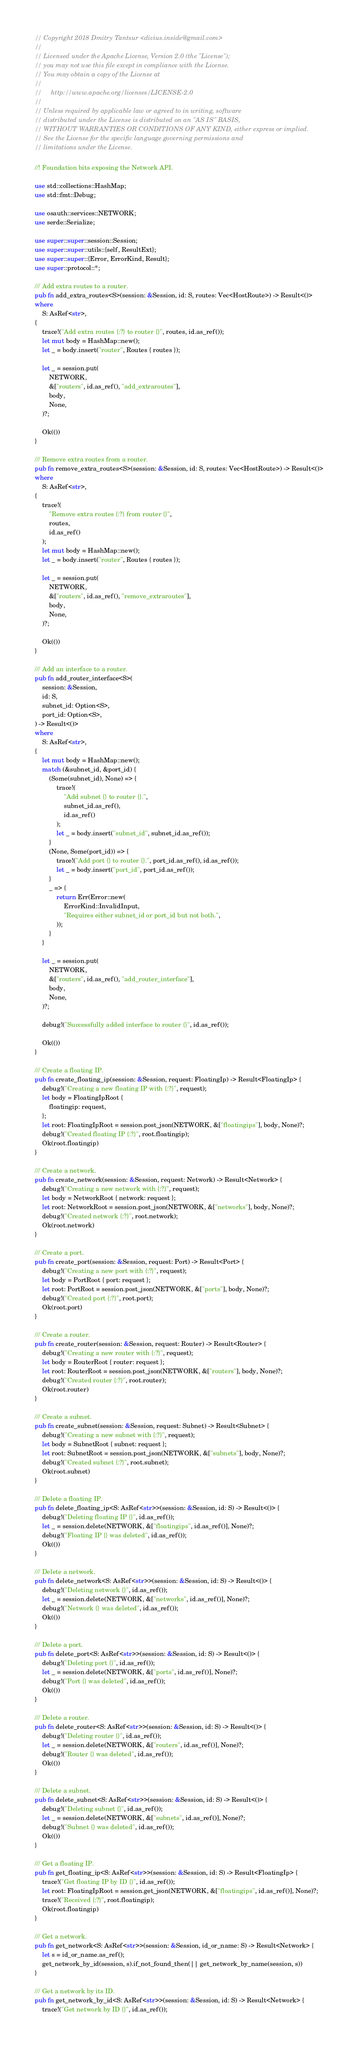Convert code to text. <code><loc_0><loc_0><loc_500><loc_500><_Rust_>// Copyright 2018 Dmitry Tantsur <divius.inside@gmail.com>
//
// Licensed under the Apache License, Version 2.0 (the "License");
// you may not use this file except in compliance with the License.
// You may obtain a copy of the License at
//
//     http://www.apache.org/licenses/LICENSE-2.0
//
// Unless required by applicable law or agreed to in writing, software
// distributed under the License is distributed on an "AS IS" BASIS,
// WITHOUT WARRANTIES OR CONDITIONS OF ANY KIND, either express or implied.
// See the License for the specific language governing permissions and
// limitations under the License.

//! Foundation bits exposing the Network API.

use std::collections::HashMap;
use std::fmt::Debug;

use osauth::services::NETWORK;
use serde::Serialize;

use super::super::session::Session;
use super::super::utils::{self, ResultExt};
use super::super::{Error, ErrorKind, Result};
use super::protocol::*;

/// Add extra routes to a router.
pub fn add_extra_routes<S>(session: &Session, id: S, routes: Vec<HostRoute>) -> Result<()>
where
    S: AsRef<str>,
{
    trace!("Add extra routes {:?} to router {}", routes, id.as_ref());
    let mut body = HashMap::new();
    let _ = body.insert("router", Routes { routes });

    let _ = session.put(
        NETWORK,
        &["routers", id.as_ref(), "add_extraroutes"],
        body,
        None,
    )?;

    Ok(())
}

/// Remove extra routes from a router.
pub fn remove_extra_routes<S>(session: &Session, id: S, routes: Vec<HostRoute>) -> Result<()>
where
    S: AsRef<str>,
{
    trace!(
        "Remove extra routes {:?} from router {}",
        routes,
        id.as_ref()
    );
    let mut body = HashMap::new();
    let _ = body.insert("router", Routes { routes });

    let _ = session.put(
        NETWORK,
        &["routers", id.as_ref(), "remove_extraroutes"],
        body,
        None,
    )?;

    Ok(())
}

/// Add an interface to a router.
pub fn add_router_interface<S>(
    session: &Session,
    id: S,
    subnet_id: Option<S>,
    port_id: Option<S>,
) -> Result<()>
where
    S: AsRef<str>,
{
    let mut body = HashMap::new();
    match (&subnet_id, &port_id) {
        (Some(subnet_id), None) => {
            trace!(
                "Add subnet {} to router {}.",
                subnet_id.as_ref(),
                id.as_ref()
            );
            let _ = body.insert("subnet_id", subnet_id.as_ref());
        }
        (None, Some(port_id)) => {
            trace!("Add port {} to router {}.", port_id.as_ref(), id.as_ref());
            let _ = body.insert("port_id", port_id.as_ref());
        }
        _ => {
            return Err(Error::new(
                ErrorKind::InvalidInput,
                "Requires either subnet_id or port_id but not both.",
            ));
        }
    }

    let _ = session.put(
        NETWORK,
        &["routers", id.as_ref(), "add_router_interface"],
        body,
        None,
    )?;

    debug!("Successfully added interface to router {}", id.as_ref());

    Ok(())
}

/// Create a floating IP.
pub fn create_floating_ip(session: &Session, request: FloatingIp) -> Result<FloatingIp> {
    debug!("Creating a new floating IP with {:?}", request);
    let body = FloatingIpRoot {
        floatingip: request,
    };
    let root: FloatingIpRoot = session.post_json(NETWORK, &["floatingips"], body, None)?;
    debug!("Created floating IP {:?}", root.floatingip);
    Ok(root.floatingip)
}

/// Create a network.
pub fn create_network(session: &Session, request: Network) -> Result<Network> {
    debug!("Creating a new network with {:?}", request);
    let body = NetworkRoot { network: request };
    let root: NetworkRoot = session.post_json(NETWORK, &["networks"], body, None)?;
    debug!("Created network {:?}", root.network);
    Ok(root.network)
}

/// Create a port.
pub fn create_port(session: &Session, request: Port) -> Result<Port> {
    debug!("Creating a new port with {:?}", request);
    let body = PortRoot { port: request };
    let root: PortRoot = session.post_json(NETWORK, &["ports"], body, None)?;
    debug!("Created port {:?}", root.port);
    Ok(root.port)
}

/// Create a router.
pub fn create_router(session: &Session, request: Router) -> Result<Router> {
    debug!("Creating a new router with {:?}", request);
    let body = RouterRoot { router: request };
    let root: RouterRoot = session.post_json(NETWORK, &["routers"], body, None)?;
    debug!("Created router {:?}", root.router);
    Ok(root.router)
}

/// Create a subnet.
pub fn create_subnet(session: &Session, request: Subnet) -> Result<Subnet> {
    debug!("Creating a new subnet with {:?}", request);
    let body = SubnetRoot { subnet: request };
    let root: SubnetRoot = session.post_json(NETWORK, &["subnets"], body, None)?;
    debug!("Created subnet {:?}", root.subnet);
    Ok(root.subnet)
}

/// Delete a floating IP.
pub fn delete_floating_ip<S: AsRef<str>>(session: &Session, id: S) -> Result<()> {
    debug!("Deleting floating IP {}", id.as_ref());
    let _ = session.delete(NETWORK, &["floatingips", id.as_ref()], None)?;
    debug!("Floating IP {} was deleted", id.as_ref());
    Ok(())
}

/// Delete a network.
pub fn delete_network<S: AsRef<str>>(session: &Session, id: S) -> Result<()> {
    debug!("Deleting network {}", id.as_ref());
    let _ = session.delete(NETWORK, &["networks", id.as_ref()], None)?;
    debug!("Network {} was deleted", id.as_ref());
    Ok(())
}

/// Delete a port.
pub fn delete_port<S: AsRef<str>>(session: &Session, id: S) -> Result<()> {
    debug!("Deleting port {}", id.as_ref());
    let _ = session.delete(NETWORK, &["ports", id.as_ref()], None)?;
    debug!("Port {} was deleted", id.as_ref());
    Ok(())
}

/// Delete a router.
pub fn delete_router<S: AsRef<str>>(session: &Session, id: S) -> Result<()> {
    debug!("Deleting router {}", id.as_ref());
    let _ = session.delete(NETWORK, &["routers", id.as_ref()], None)?;
    debug!("Router {} was deleted", id.as_ref());
    Ok(())
}

/// Delete a subnet.
pub fn delete_subnet<S: AsRef<str>>(session: &Session, id: S) -> Result<()> {
    debug!("Deleting subnet {}", id.as_ref());
    let _ = session.delete(NETWORK, &["subnets", id.as_ref()], None)?;
    debug!("Subnet {} was deleted", id.as_ref());
    Ok(())
}

/// Get a floating IP.
pub fn get_floating_ip<S: AsRef<str>>(session: &Session, id: S) -> Result<FloatingIp> {
    trace!("Get floating IP by ID {}", id.as_ref());
    let root: FloatingIpRoot = session.get_json(NETWORK, &["floatingips", id.as_ref()], None)?;
    trace!("Received {:?}", root.floatingip);
    Ok(root.floatingip)
}

/// Get a network.
pub fn get_network<S: AsRef<str>>(session: &Session, id_or_name: S) -> Result<Network> {
    let s = id_or_name.as_ref();
    get_network_by_id(session, s).if_not_found_then(|| get_network_by_name(session, s))
}

/// Get a network by its ID.
pub fn get_network_by_id<S: AsRef<str>>(session: &Session, id: S) -> Result<Network> {
    trace!("Get network by ID {}", id.as_ref());</code> 